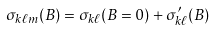Convert formula to latex. <formula><loc_0><loc_0><loc_500><loc_500>\sigma _ { k \ell m } ( B ) = \sigma _ { k \ell } ( B = 0 ) + \sigma _ { k \ell } ^ { \prime } ( B )</formula> 